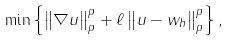<formula> <loc_0><loc_0><loc_500><loc_500>\min \left \{ \left \| \nabla u \right \| _ { p } ^ { p } + \ell \left \| u - w _ { h } \right \| _ { p } ^ { p } \right \} ,</formula> 